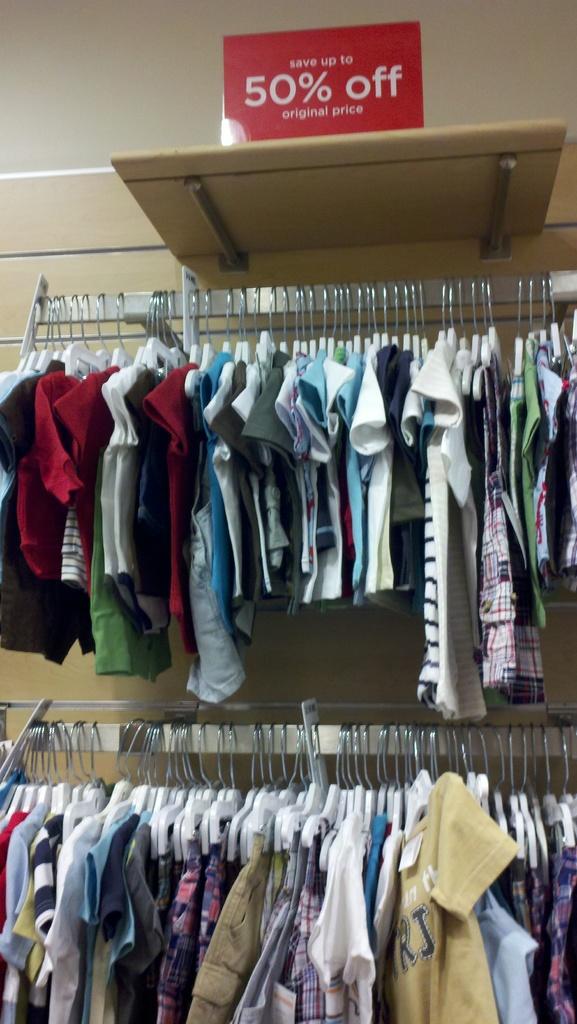Are the shirts 50% off?
Keep it short and to the point. Yes. 